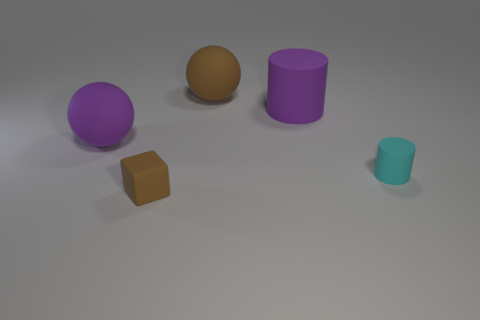There is a big ball that is the same color as the big matte cylinder; what material is it?
Offer a very short reply. Rubber. Does the large rubber cylinder have the same color as the tiny rubber cube?
Your answer should be very brief. No. Is there another small rubber thing that has the same shape as the tiny cyan matte thing?
Your answer should be very brief. No. How many brown objects are matte cylinders or small objects?
Offer a very short reply. 1. Are there any other cylinders that have the same size as the cyan rubber cylinder?
Offer a terse response. No. What number of tiny green rubber cubes are there?
Provide a short and direct response. 0. What number of tiny objects are either brown blocks or cylinders?
Your answer should be very brief. 2. What is the color of the large rubber ball in front of the big purple rubber object to the right of the tiny object that is in front of the tiny cylinder?
Your response must be concise. Purple. What number of other objects are the same color as the cube?
Offer a terse response. 1. What number of metallic objects are cyan blocks or big brown objects?
Your response must be concise. 0. 